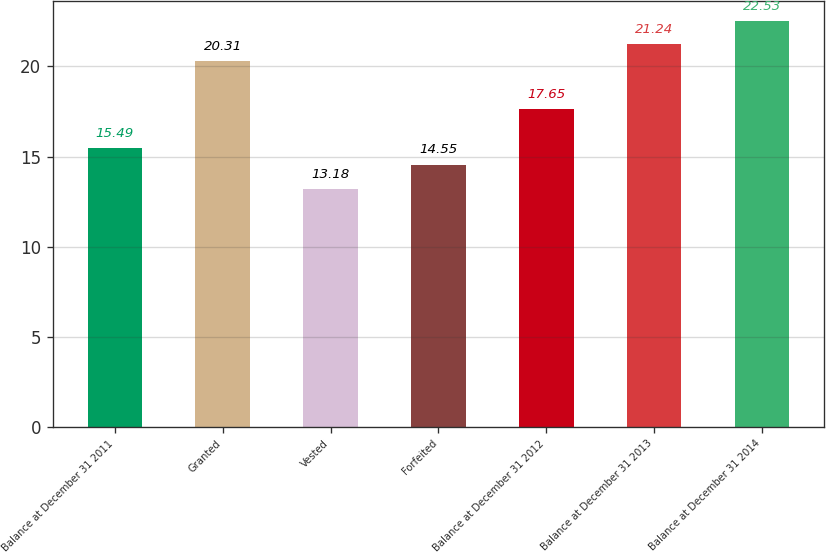Convert chart to OTSL. <chart><loc_0><loc_0><loc_500><loc_500><bar_chart><fcel>Balance at December 31 2011<fcel>Granted<fcel>Vested<fcel>Forfeited<fcel>Balance at December 31 2012<fcel>Balance at December 31 2013<fcel>Balance at December 31 2014<nl><fcel>15.49<fcel>20.31<fcel>13.18<fcel>14.55<fcel>17.65<fcel>21.24<fcel>22.53<nl></chart> 